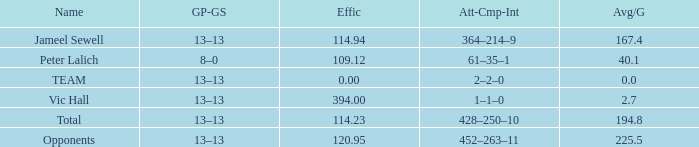7? 394.0. 